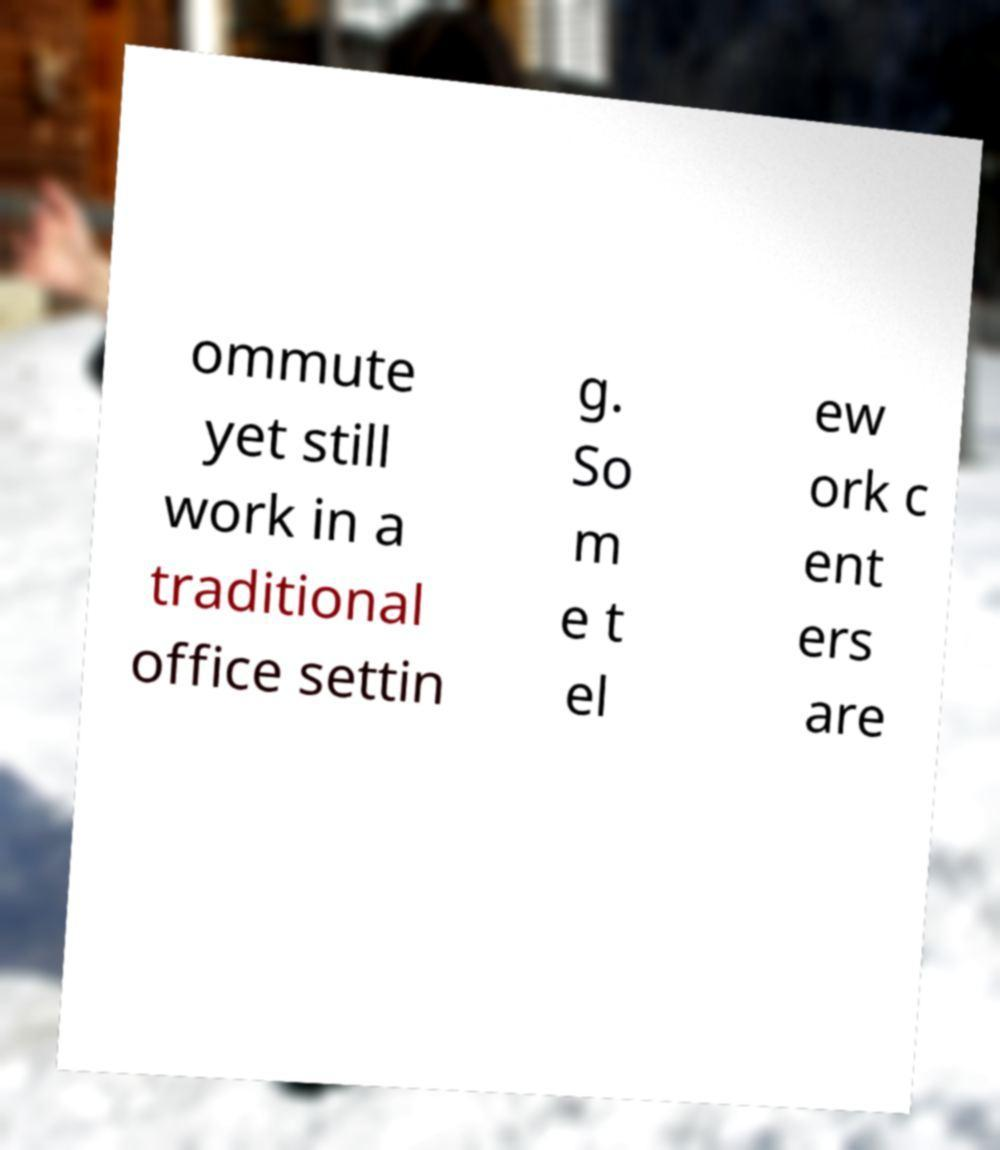There's text embedded in this image that I need extracted. Can you transcribe it verbatim? ommute yet still work in a traditional office settin g. So m e t el ew ork c ent ers are 